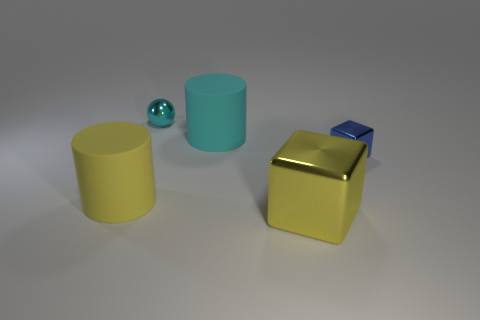Are there fewer blue blocks to the left of the large yellow block than rubber cylinders that are in front of the big cyan cylinder?
Provide a short and direct response. Yes. There is a small blue shiny block; are there any rubber cylinders behind it?
Provide a succinct answer. Yes. How many objects are rubber things that are left of the big cyan matte cylinder or big matte objects that are left of the small cyan metal sphere?
Keep it short and to the point. 1. What number of large matte things have the same color as the big metal cube?
Make the answer very short. 1. The other big shiny thing that is the same shape as the blue thing is what color?
Ensure brevity in your answer.  Yellow. The large object that is to the left of the yellow metal thing and in front of the tiny blue shiny thing has what shape?
Make the answer very short. Cylinder. Are there more tiny blue things than tiny objects?
Your answer should be very brief. No. What is the large block made of?
Provide a succinct answer. Metal. There is another object that is the same shape as the big metal object; what size is it?
Make the answer very short. Small. There is a large thing that is to the left of the big cyan thing; are there any large matte cylinders to the right of it?
Your answer should be very brief. Yes. 